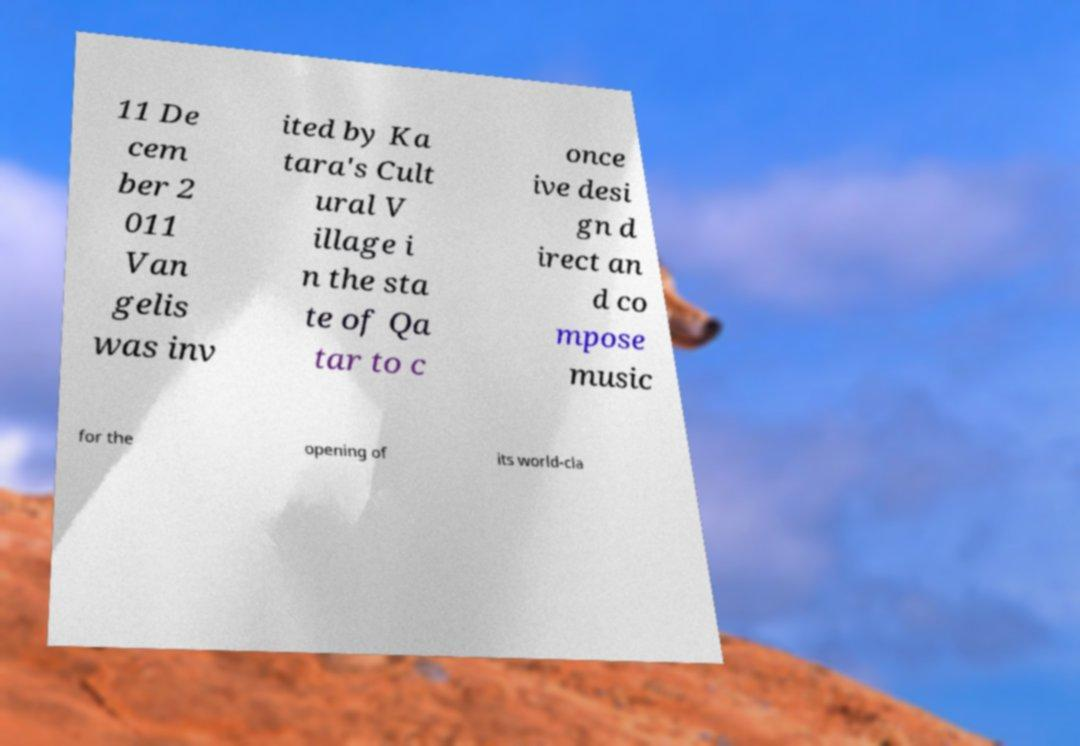Could you extract and type out the text from this image? 11 De cem ber 2 011 Van gelis was inv ited by Ka tara's Cult ural V illage i n the sta te of Qa tar to c once ive desi gn d irect an d co mpose music for the opening of its world-cla 